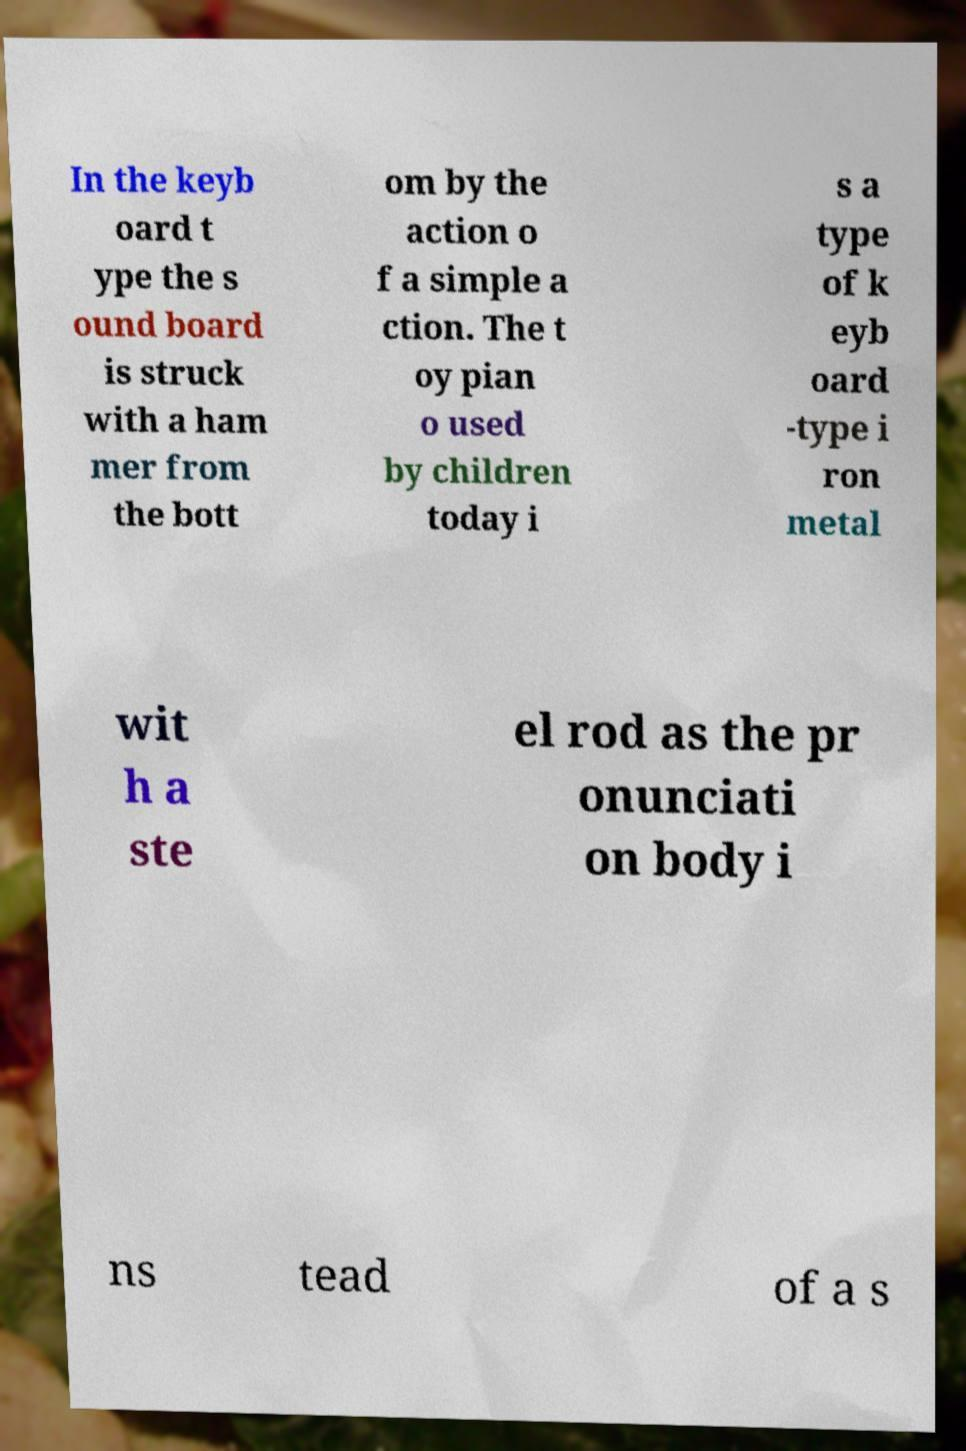Could you extract and type out the text from this image? In the keyb oard t ype the s ound board is struck with a ham mer from the bott om by the action o f a simple a ction. The t oy pian o used by children today i s a type of k eyb oard -type i ron metal wit h a ste el rod as the pr onunciati on body i ns tead of a s 